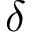Convert formula to latex. <formula><loc_0><loc_0><loc_500><loc_500>\delta</formula> 